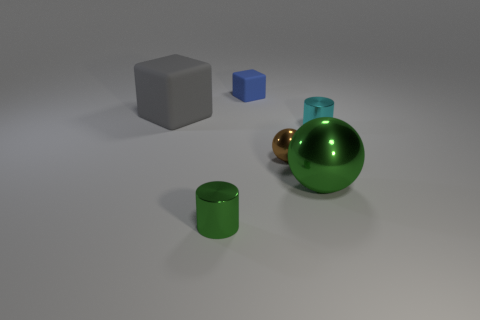Add 1 green shiny things. How many objects exist? 7 Subtract all spheres. How many objects are left? 4 Subtract 0 purple cylinders. How many objects are left? 6 Subtract 1 spheres. How many spheres are left? 1 Subtract all yellow balls. Subtract all cyan cylinders. How many balls are left? 2 Subtract all yellow spheres. How many blue cubes are left? 1 Subtract all rubber objects. Subtract all brown shiny objects. How many objects are left? 3 Add 6 gray matte blocks. How many gray matte blocks are left? 7 Add 1 big purple balls. How many big purple balls exist? 1 